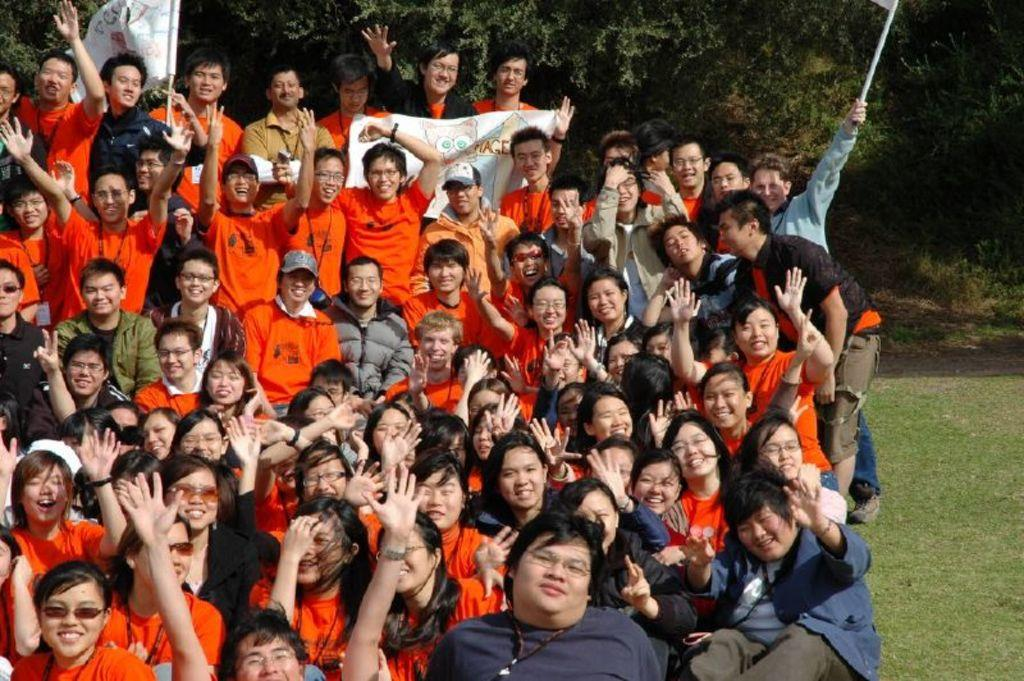What are the people in the image wearing? The persons in the image are wearing clothes. What are the two persons holding in their hands? Two persons are holding flags in their hands. What type of natural vegetation can be seen in the image? There are trees visible at the top of the image. What type of rod is being used for digestion in the image? There is no rod or reference to digestion present in the image. 